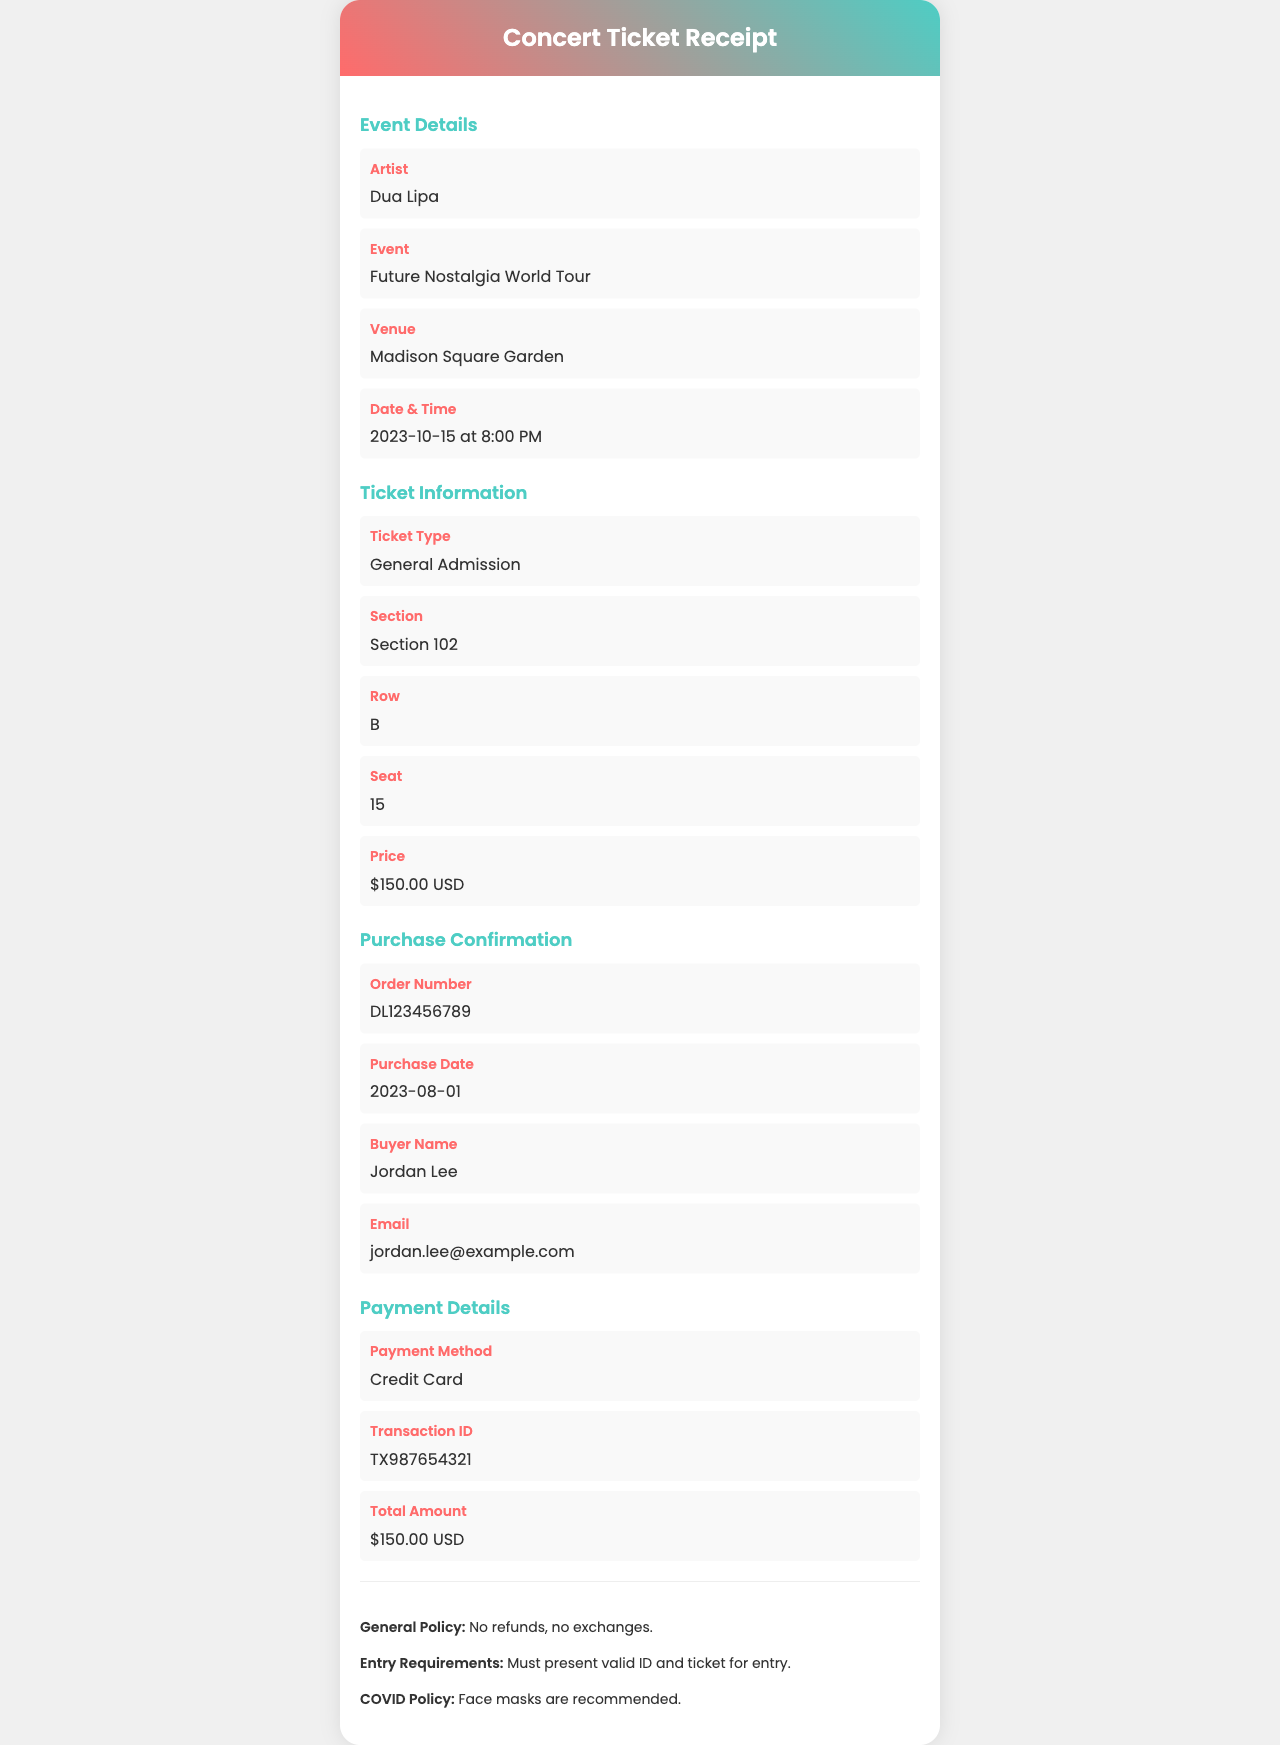What is the name of the artist? The name of the artist is listed in the event details section under "Artist".
Answer: Dua Lipa What is the date and time of the event? The date and time can be found in the event details section under "Date & Time".
Answer: 2023-10-15 at 8:00 PM What is the seating section of the ticket? The seating section is specified in the ticket information section under "Section".
Answer: Section 102 What is the ticket price? The ticket price is mentioned in the ticket information section under "Price".
Answer: $150.00 USD What is the order number for this ticket purchase? The order number is located in the purchase confirmation section under "Order Number".
Answer: DL123456789 What method was used for payment? The payment method is mentioned in the payment details section under "Payment Method".
Answer: Credit Card How many days before the event was the ticket purchased? The purchase date and event date must be compared to calculate the difference. The ticket was purchased on 2023-08-01.
Answer: 75 What is the total amount paid for the ticket? The total amount is found in the payment details section under "Total Amount".
Answer: $150.00 USD What is the venue for the concert? The venue is indicated in the event details section under "Venue".
Answer: Madison Square Garden 